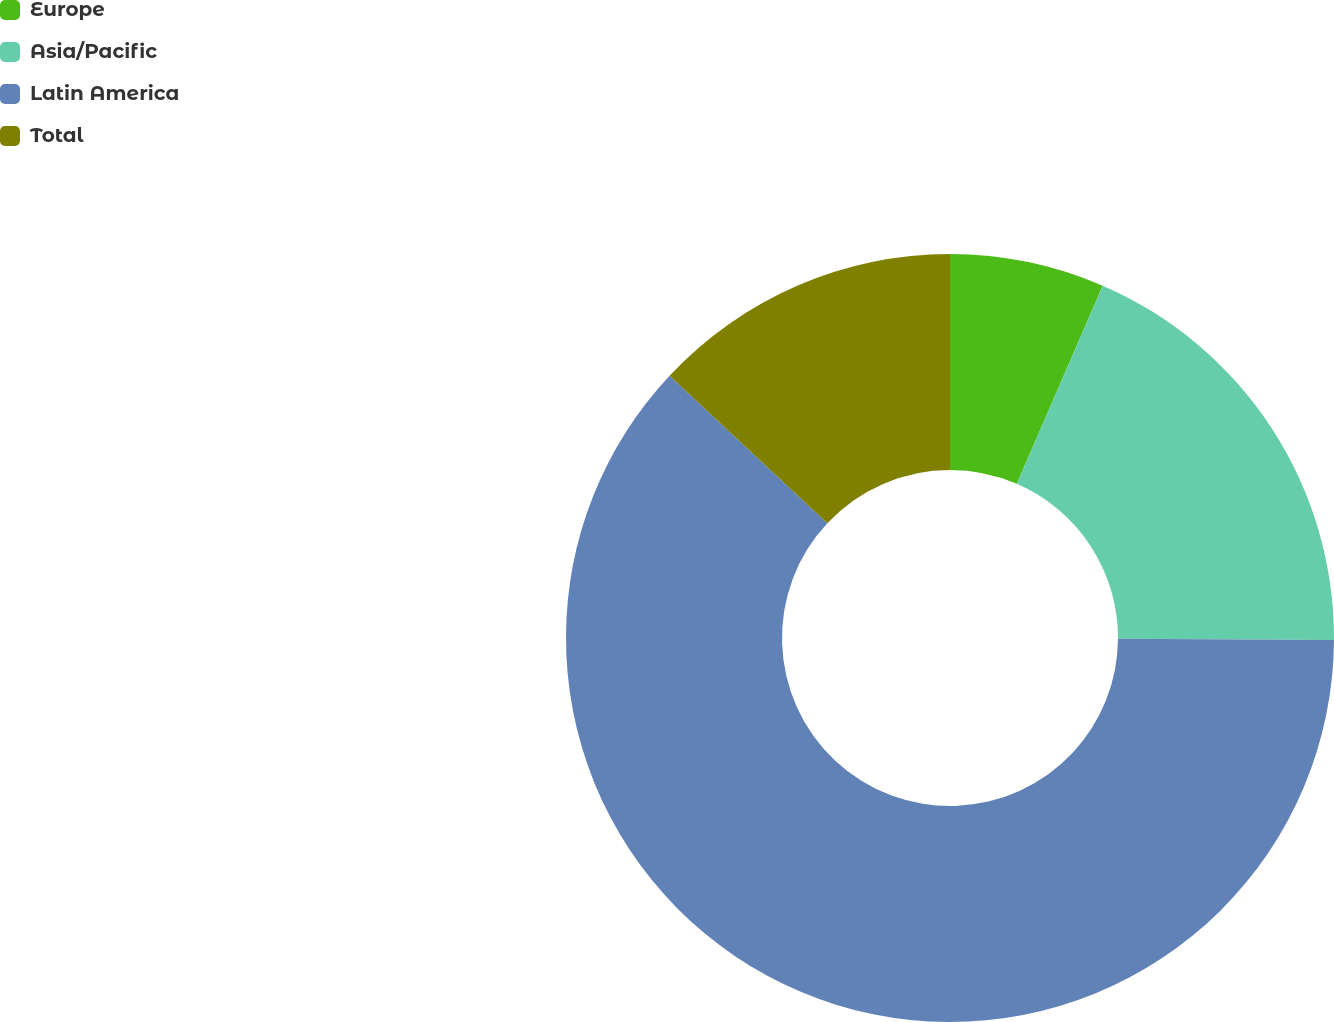Convert chart to OTSL. <chart><loc_0><loc_0><loc_500><loc_500><pie_chart><fcel>Europe<fcel>Asia/Pacific<fcel>Latin America<fcel>Total<nl><fcel>6.51%<fcel>18.57%<fcel>61.89%<fcel>13.03%<nl></chart> 